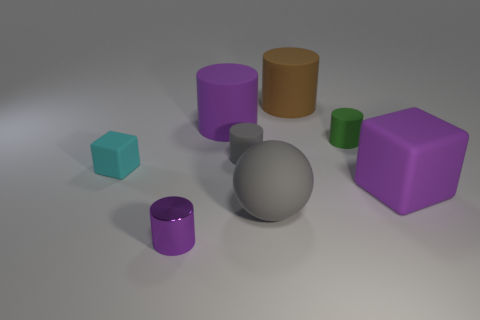What shape is the tiny object that is on the right side of the large object that is in front of the large block?
Ensure brevity in your answer.  Cylinder. How many other things are the same shape as the cyan object?
Provide a succinct answer. 1. How big is the gray matte object in front of the block that is left of the metal cylinder?
Your answer should be very brief. Large. Is there a big cyan shiny cylinder?
Your response must be concise. No. What number of tiny cylinders are in front of the big matte sphere on the right side of the large purple rubber cylinder?
Your answer should be compact. 1. What is the shape of the object that is in front of the gray ball?
Ensure brevity in your answer.  Cylinder. The purple object in front of the large purple rubber object on the right side of the gray object behind the tiny cyan block is made of what material?
Your answer should be very brief. Metal. How many other things are the same size as the green thing?
Give a very brief answer. 3. There is a gray thing that is the same shape as the tiny purple metallic object; what is it made of?
Offer a terse response. Rubber. The big rubber cube has what color?
Offer a very short reply. Purple. 